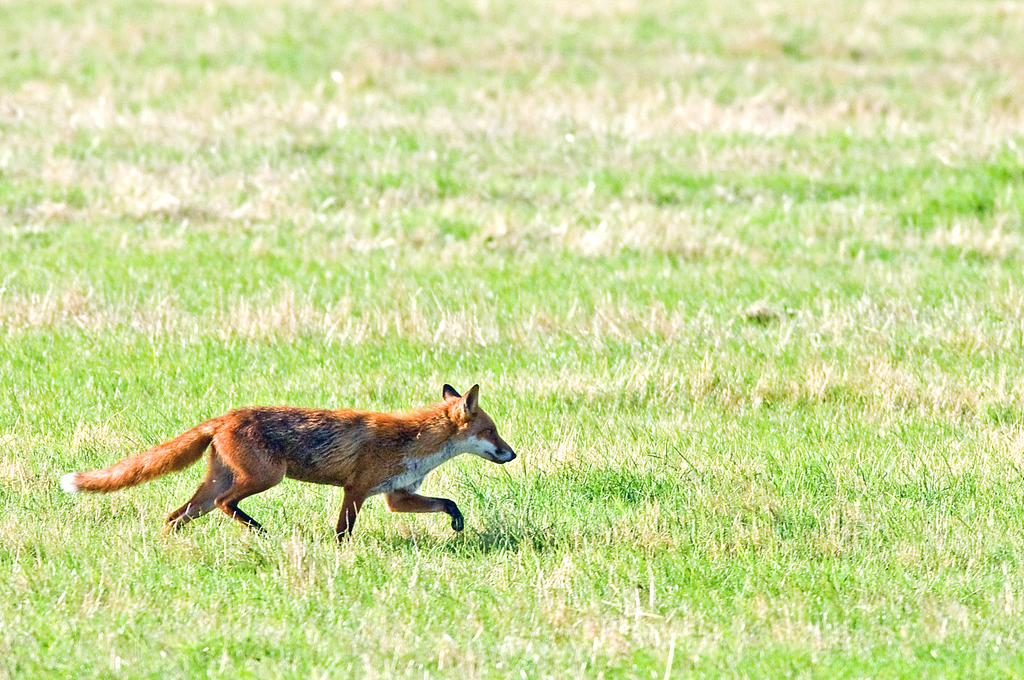What type of animal is in the image? There is a brown fox in the image. What is the fox doing in the image? The fox is running in the image. What is the surface the fox is running on? The fox is on the grass in the image. What type of milk is the fox drinking in the image? There is no milk present in the image; the fox is running on the grass. How many giants are visible in the image? There are no giants present in the image; it features a brown fox running on the grass. 